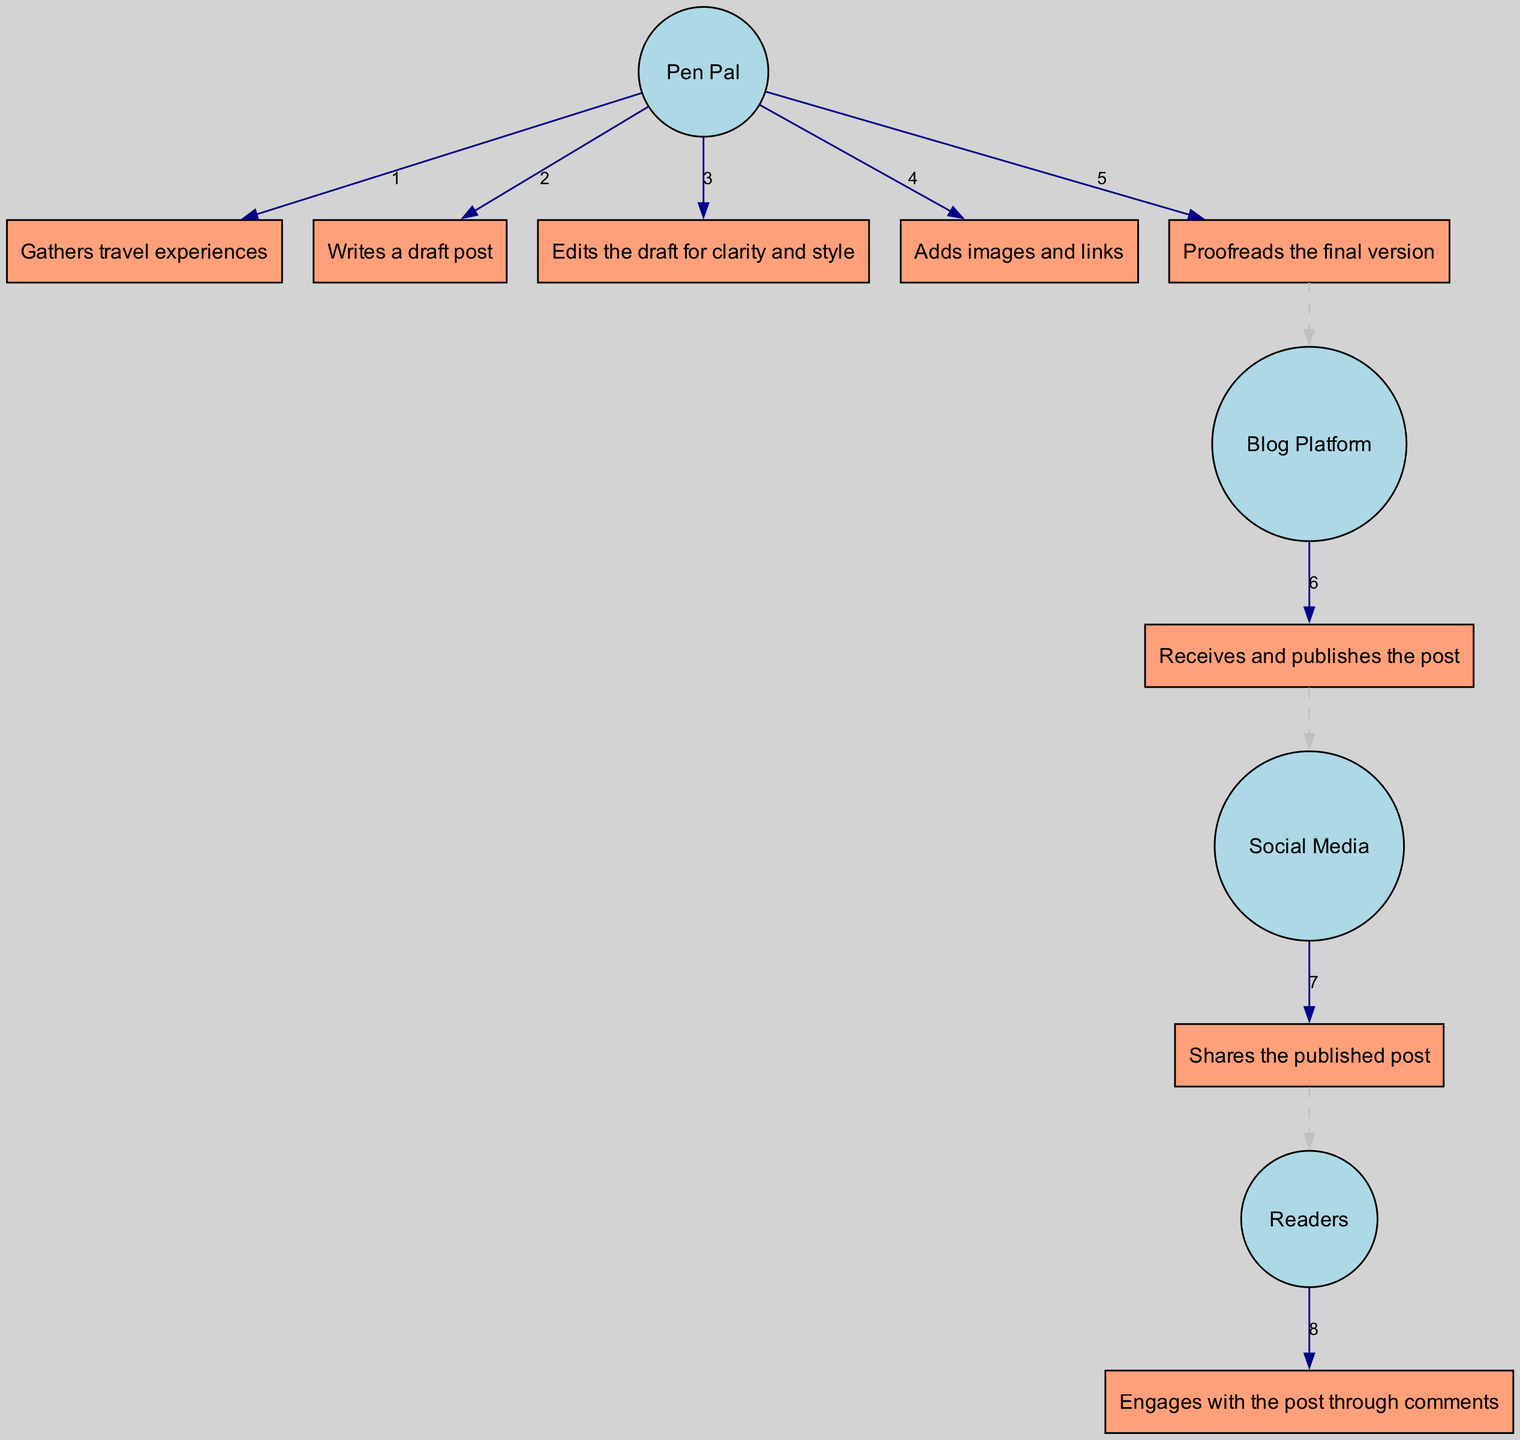What is the first action taken by the Pen Pal? The diagram shows that the first action of the Pen Pal is "Gathers travel experiences." This can be seen at the top of the sequence diagram where the sequence of actions begins.
Answer: Gathers travel experiences How many actions does the Pen Pal perform? By counting the actions listed under the Pen Pal in the diagram, there are five distinct actions. These are all the actions labeled under the Pen Pal's flow.
Answer: Five Which actor receives the final post for publication? The Blog Platform is the actor that receives the post for publication. This is shown in the flow where the Pen Pal's actions lead to the Blog Platform.
Answer: Blog Platform What action comes after proofreading? According to the sequence diagram, the action following "Proofreads the final version" is "Receives and publishes the post." This indicates the flow of actions and highlights the role of the Blog Platform.
Answer: Receives and publishes the post What type of interaction do Readers have with the published post? Readers engage with the post through comments. This interaction is shown as the last action in the flow where readers are depicted responding to the published content.
Answer: Engages with the post through comments How many edges connect the Pen Pal to actions? The Pen Pal has five outgoing edges connecting it to its actions, as illustrated by the connections from the Pen Pal node to each of its five subsequent actions in the diagram.
Answer: Five What kind of relationship is shown between the action "Adds images and links" and the next actor? The action "Adds images and links" has a dashed edge leading to the next actor, indicating a non-direct or optional relationship with the Blog Platform, as the Pen Pal can add content before publishing.
Answer: Dashed edge Which actor shares the published post? The Social Media actor is responsible for sharing the published post. This is clear from the sequence flow that indicates the action following the publication involves sharing across social platforms.
Answer: Social Media 